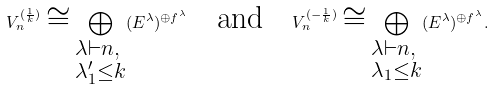Convert formula to latex. <formula><loc_0><loc_0><loc_500><loc_500>V _ { n } ^ { ( \frac { 1 } { k } ) } \cong \bigoplus _ { \begin{subarray} { c } \lambda \vdash n , \\ \lambda ^ { \prime } _ { 1 } \leq k \end{subarray} } ( E ^ { \lambda } ) ^ { \oplus f ^ { \lambda } } \quad \text {and} \quad V _ { n } ^ { ( - \frac { 1 } { k } ) } \cong \bigoplus _ { \begin{subarray} { c } \lambda \vdash n , \\ \lambda _ { 1 } \leq k \end{subarray} } ( E ^ { \lambda } ) ^ { \oplus f ^ { \lambda } } .</formula> 